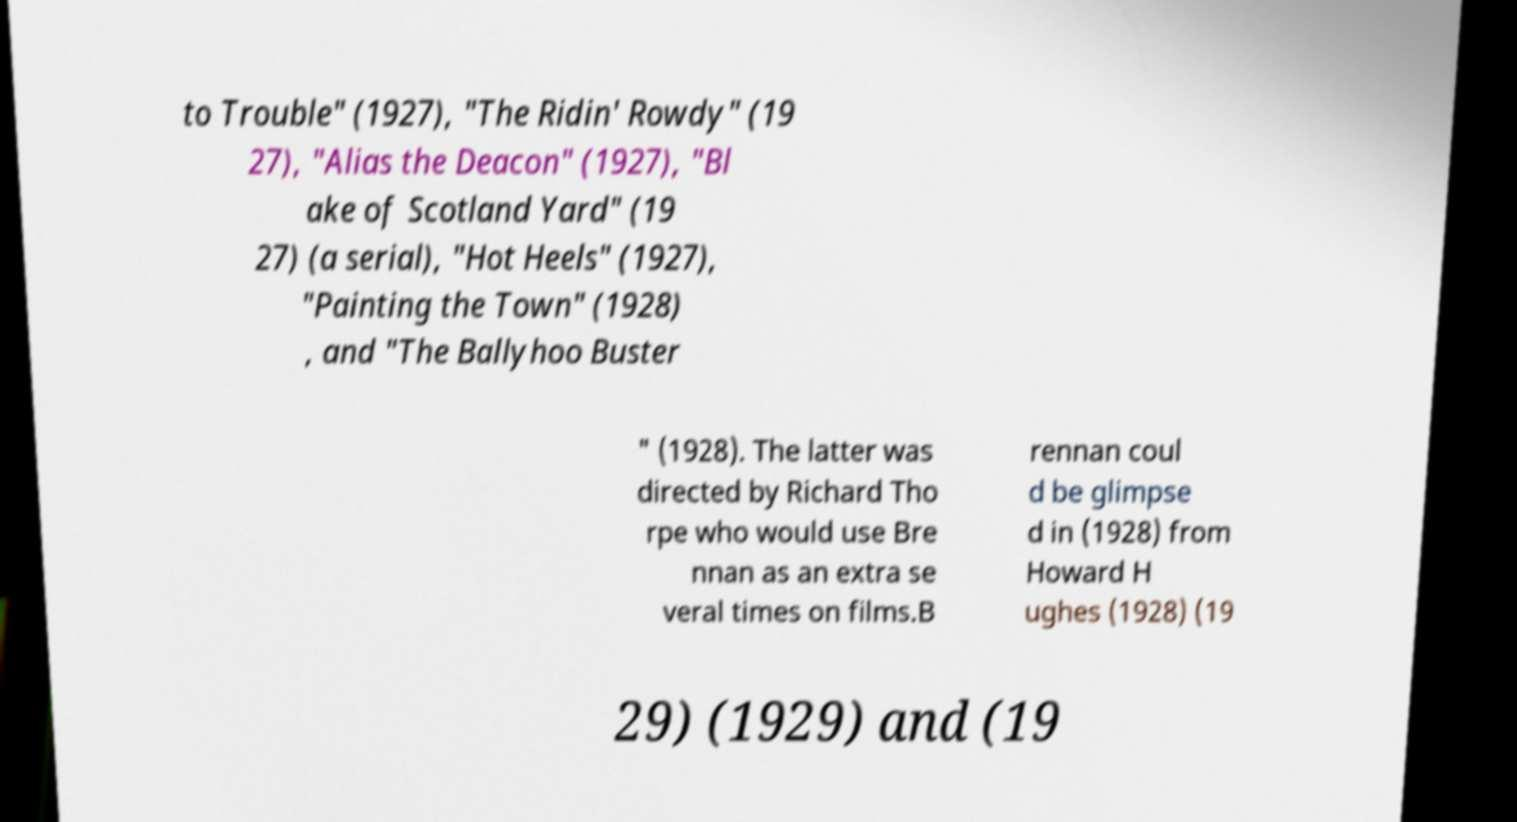For documentation purposes, I need the text within this image transcribed. Could you provide that? to Trouble" (1927), "The Ridin' Rowdy" (19 27), "Alias the Deacon" (1927), "Bl ake of Scotland Yard" (19 27) (a serial), "Hot Heels" (1927), "Painting the Town" (1928) , and "The Ballyhoo Buster " (1928). The latter was directed by Richard Tho rpe who would use Bre nnan as an extra se veral times on films.B rennan coul d be glimpse d in (1928) from Howard H ughes (1928) (19 29) (1929) and (19 